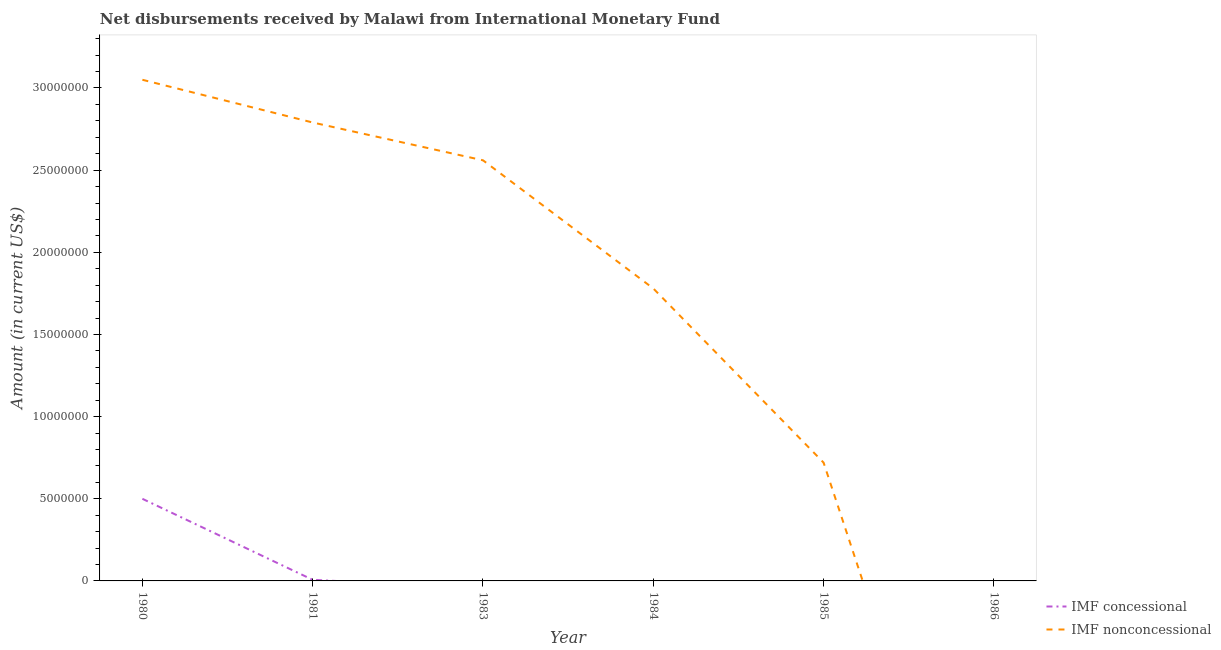How many different coloured lines are there?
Give a very brief answer. 2. Is the number of lines equal to the number of legend labels?
Provide a short and direct response. No. What is the net non concessional disbursements from imf in 1985?
Your answer should be compact. 7.20e+06. Across all years, what is the maximum net non concessional disbursements from imf?
Your response must be concise. 3.05e+07. Across all years, what is the minimum net non concessional disbursements from imf?
Offer a terse response. 0. In which year was the net non concessional disbursements from imf maximum?
Your answer should be very brief. 1980. What is the total net concessional disbursements from imf in the graph?
Your answer should be compact. 5.06e+06. What is the difference between the net concessional disbursements from imf in 1980 and that in 1981?
Give a very brief answer. 4.93e+06. What is the difference between the net non concessional disbursements from imf in 1986 and the net concessional disbursements from imf in 1980?
Provide a short and direct response. -5.00e+06. What is the average net concessional disbursements from imf per year?
Give a very brief answer. 8.44e+05. In the year 1981, what is the difference between the net concessional disbursements from imf and net non concessional disbursements from imf?
Offer a very short reply. -2.78e+07. In how many years, is the net non concessional disbursements from imf greater than 22000000 US$?
Your response must be concise. 3. What is the ratio of the net non concessional disbursements from imf in 1981 to that in 1985?
Your answer should be very brief. 3.88. Is the net non concessional disbursements from imf in 1980 less than that in 1985?
Offer a terse response. No. What is the difference between the highest and the second highest net non concessional disbursements from imf?
Make the answer very short. 2.60e+06. What is the difference between the highest and the lowest net concessional disbursements from imf?
Give a very brief answer. 5.00e+06. In how many years, is the net non concessional disbursements from imf greater than the average net non concessional disbursements from imf taken over all years?
Your answer should be very brief. 3. How many lines are there?
Offer a terse response. 2. What is the difference between two consecutive major ticks on the Y-axis?
Your answer should be very brief. 5.00e+06. Where does the legend appear in the graph?
Give a very brief answer. Bottom right. What is the title of the graph?
Ensure brevity in your answer.  Net disbursements received by Malawi from International Monetary Fund. Does "Central government" appear as one of the legend labels in the graph?
Make the answer very short. No. What is the label or title of the X-axis?
Keep it short and to the point. Year. What is the label or title of the Y-axis?
Make the answer very short. Amount (in current US$). What is the Amount (in current US$) of IMF concessional in 1980?
Provide a succinct answer. 5.00e+06. What is the Amount (in current US$) in IMF nonconcessional in 1980?
Provide a succinct answer. 3.05e+07. What is the Amount (in current US$) in IMF concessional in 1981?
Make the answer very short. 6.70e+04. What is the Amount (in current US$) in IMF nonconcessional in 1981?
Provide a short and direct response. 2.79e+07. What is the Amount (in current US$) in IMF nonconcessional in 1983?
Offer a very short reply. 2.56e+07. What is the Amount (in current US$) in IMF concessional in 1984?
Ensure brevity in your answer.  0. What is the Amount (in current US$) of IMF nonconcessional in 1984?
Offer a terse response. 1.78e+07. What is the Amount (in current US$) of IMF concessional in 1985?
Your response must be concise. 0. What is the Amount (in current US$) in IMF nonconcessional in 1985?
Keep it short and to the point. 7.20e+06. What is the Amount (in current US$) of IMF nonconcessional in 1986?
Your answer should be very brief. 0. Across all years, what is the maximum Amount (in current US$) in IMF concessional?
Provide a short and direct response. 5.00e+06. Across all years, what is the maximum Amount (in current US$) of IMF nonconcessional?
Your answer should be very brief. 3.05e+07. What is the total Amount (in current US$) in IMF concessional in the graph?
Make the answer very short. 5.06e+06. What is the total Amount (in current US$) in IMF nonconcessional in the graph?
Provide a short and direct response. 1.09e+08. What is the difference between the Amount (in current US$) in IMF concessional in 1980 and that in 1981?
Offer a terse response. 4.93e+06. What is the difference between the Amount (in current US$) in IMF nonconcessional in 1980 and that in 1981?
Ensure brevity in your answer.  2.60e+06. What is the difference between the Amount (in current US$) of IMF nonconcessional in 1980 and that in 1983?
Offer a terse response. 4.90e+06. What is the difference between the Amount (in current US$) of IMF nonconcessional in 1980 and that in 1984?
Make the answer very short. 1.27e+07. What is the difference between the Amount (in current US$) of IMF nonconcessional in 1980 and that in 1985?
Provide a short and direct response. 2.33e+07. What is the difference between the Amount (in current US$) of IMF nonconcessional in 1981 and that in 1983?
Ensure brevity in your answer.  2.30e+06. What is the difference between the Amount (in current US$) of IMF nonconcessional in 1981 and that in 1984?
Offer a very short reply. 1.01e+07. What is the difference between the Amount (in current US$) in IMF nonconcessional in 1981 and that in 1985?
Ensure brevity in your answer.  2.07e+07. What is the difference between the Amount (in current US$) in IMF nonconcessional in 1983 and that in 1984?
Your answer should be very brief. 7.80e+06. What is the difference between the Amount (in current US$) of IMF nonconcessional in 1983 and that in 1985?
Provide a short and direct response. 1.84e+07. What is the difference between the Amount (in current US$) of IMF nonconcessional in 1984 and that in 1985?
Your answer should be compact. 1.06e+07. What is the difference between the Amount (in current US$) in IMF concessional in 1980 and the Amount (in current US$) in IMF nonconcessional in 1981?
Ensure brevity in your answer.  -2.29e+07. What is the difference between the Amount (in current US$) of IMF concessional in 1980 and the Amount (in current US$) of IMF nonconcessional in 1983?
Provide a short and direct response. -2.06e+07. What is the difference between the Amount (in current US$) of IMF concessional in 1980 and the Amount (in current US$) of IMF nonconcessional in 1984?
Make the answer very short. -1.28e+07. What is the difference between the Amount (in current US$) in IMF concessional in 1980 and the Amount (in current US$) in IMF nonconcessional in 1985?
Provide a short and direct response. -2.20e+06. What is the difference between the Amount (in current US$) of IMF concessional in 1981 and the Amount (in current US$) of IMF nonconcessional in 1983?
Ensure brevity in your answer.  -2.55e+07. What is the difference between the Amount (in current US$) of IMF concessional in 1981 and the Amount (in current US$) of IMF nonconcessional in 1984?
Your response must be concise. -1.77e+07. What is the difference between the Amount (in current US$) in IMF concessional in 1981 and the Amount (in current US$) in IMF nonconcessional in 1985?
Your response must be concise. -7.13e+06. What is the average Amount (in current US$) of IMF concessional per year?
Keep it short and to the point. 8.44e+05. What is the average Amount (in current US$) in IMF nonconcessional per year?
Make the answer very short. 1.82e+07. In the year 1980, what is the difference between the Amount (in current US$) in IMF concessional and Amount (in current US$) in IMF nonconcessional?
Provide a succinct answer. -2.55e+07. In the year 1981, what is the difference between the Amount (in current US$) in IMF concessional and Amount (in current US$) in IMF nonconcessional?
Your answer should be very brief. -2.78e+07. What is the ratio of the Amount (in current US$) of IMF concessional in 1980 to that in 1981?
Give a very brief answer. 74.6. What is the ratio of the Amount (in current US$) of IMF nonconcessional in 1980 to that in 1981?
Offer a terse response. 1.09. What is the ratio of the Amount (in current US$) of IMF nonconcessional in 1980 to that in 1983?
Offer a very short reply. 1.19. What is the ratio of the Amount (in current US$) in IMF nonconcessional in 1980 to that in 1984?
Make the answer very short. 1.71. What is the ratio of the Amount (in current US$) in IMF nonconcessional in 1980 to that in 1985?
Your answer should be compact. 4.24. What is the ratio of the Amount (in current US$) of IMF nonconcessional in 1981 to that in 1983?
Your answer should be compact. 1.09. What is the ratio of the Amount (in current US$) of IMF nonconcessional in 1981 to that in 1984?
Your response must be concise. 1.57. What is the ratio of the Amount (in current US$) of IMF nonconcessional in 1981 to that in 1985?
Ensure brevity in your answer.  3.88. What is the ratio of the Amount (in current US$) of IMF nonconcessional in 1983 to that in 1984?
Give a very brief answer. 1.44. What is the ratio of the Amount (in current US$) of IMF nonconcessional in 1983 to that in 1985?
Your answer should be very brief. 3.56. What is the ratio of the Amount (in current US$) in IMF nonconcessional in 1984 to that in 1985?
Offer a terse response. 2.47. What is the difference between the highest and the second highest Amount (in current US$) of IMF nonconcessional?
Ensure brevity in your answer.  2.60e+06. What is the difference between the highest and the lowest Amount (in current US$) in IMF concessional?
Make the answer very short. 5.00e+06. What is the difference between the highest and the lowest Amount (in current US$) of IMF nonconcessional?
Your response must be concise. 3.05e+07. 